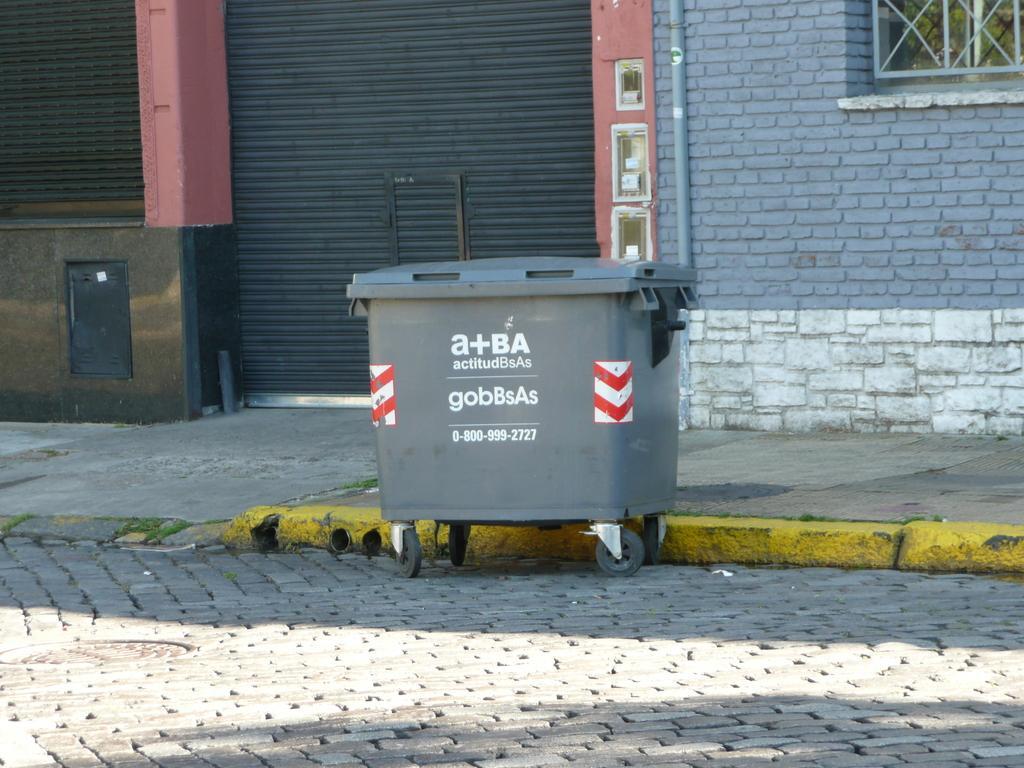Could you give a brief overview of what you see in this image? In this picture it seems like a garbage box in the center and there is a window, pipe, shutters and a wall in the background area. 